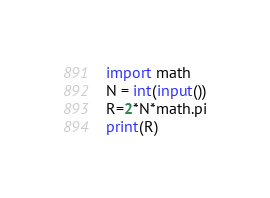<code> <loc_0><loc_0><loc_500><loc_500><_Python_>import math
N = int(input())
R=2*N*math.pi
print(R)</code> 